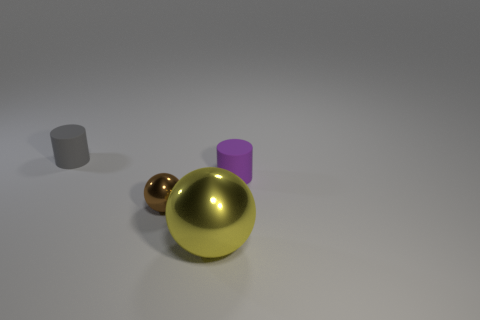Add 1 gray things. How many objects exist? 5 Subtract 1 cylinders. How many cylinders are left? 1 Subtract all purple balls. How many gray cylinders are left? 1 Add 3 purple rubber cylinders. How many purple rubber cylinders exist? 4 Subtract 1 gray cylinders. How many objects are left? 3 Subtract all yellow spheres. Subtract all purple cylinders. How many spheres are left? 1 Subtract all big yellow spheres. Subtract all large yellow metal objects. How many objects are left? 2 Add 3 small matte cylinders. How many small matte cylinders are left? 5 